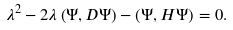Convert formula to latex. <formula><loc_0><loc_0><loc_500><loc_500>\lambda ^ { 2 } - 2 \lambda \left ( \Psi , D \Psi \right ) - \left ( \Psi , H \Psi \right ) = 0 .</formula> 